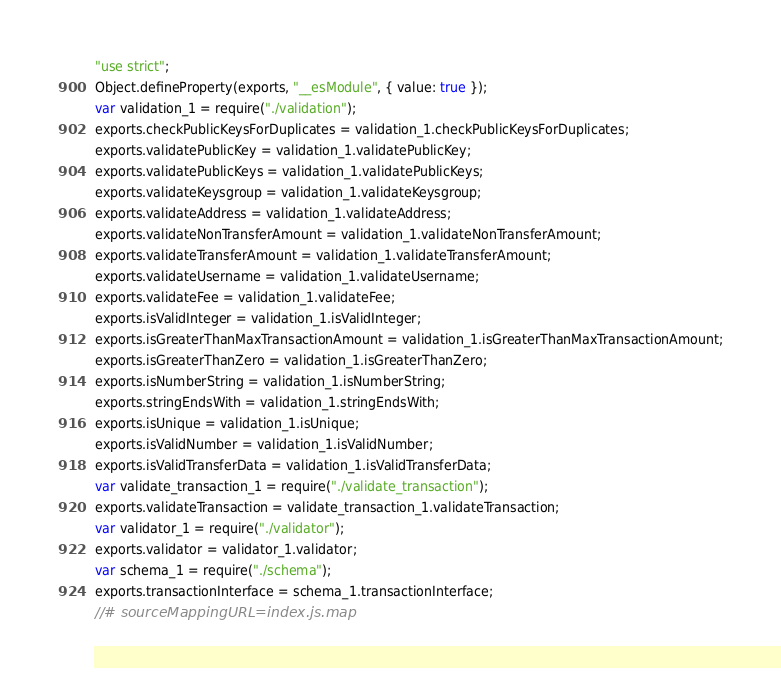Convert code to text. <code><loc_0><loc_0><loc_500><loc_500><_JavaScript_>"use strict";
Object.defineProperty(exports, "__esModule", { value: true });
var validation_1 = require("./validation");
exports.checkPublicKeysForDuplicates = validation_1.checkPublicKeysForDuplicates;
exports.validatePublicKey = validation_1.validatePublicKey;
exports.validatePublicKeys = validation_1.validatePublicKeys;
exports.validateKeysgroup = validation_1.validateKeysgroup;
exports.validateAddress = validation_1.validateAddress;
exports.validateNonTransferAmount = validation_1.validateNonTransferAmount;
exports.validateTransferAmount = validation_1.validateTransferAmount;
exports.validateUsername = validation_1.validateUsername;
exports.validateFee = validation_1.validateFee;
exports.isValidInteger = validation_1.isValidInteger;
exports.isGreaterThanMaxTransactionAmount = validation_1.isGreaterThanMaxTransactionAmount;
exports.isGreaterThanZero = validation_1.isGreaterThanZero;
exports.isNumberString = validation_1.isNumberString;
exports.stringEndsWith = validation_1.stringEndsWith;
exports.isUnique = validation_1.isUnique;
exports.isValidNumber = validation_1.isValidNumber;
exports.isValidTransferData = validation_1.isValidTransferData;
var validate_transaction_1 = require("./validate_transaction");
exports.validateTransaction = validate_transaction_1.validateTransaction;
var validator_1 = require("./validator");
exports.validator = validator_1.validator;
var schema_1 = require("./schema");
exports.transactionInterface = schema_1.transactionInterface;
//# sourceMappingURL=index.js.map</code> 